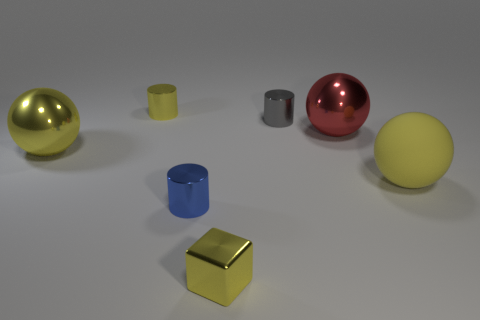Subtract all yellow spheres. How many spheres are left? 1 Subtract all green cubes. How many yellow balls are left? 2 Add 1 metal balls. How many objects exist? 8 Subtract 1 cubes. How many cubes are left? 0 Subtract all red balls. How many balls are left? 2 Add 5 tiny yellow metal cylinders. How many tiny yellow metal cylinders are left? 6 Add 2 yellow cylinders. How many yellow cylinders exist? 3 Subtract 0 gray cubes. How many objects are left? 7 Subtract all spheres. How many objects are left? 4 Subtract all blue balls. Subtract all red cubes. How many balls are left? 3 